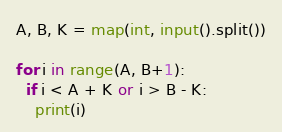<code> <loc_0><loc_0><loc_500><loc_500><_Python_>A, B, K = map(int, input().split())

for i in range(A, B+1):
  if i < A + K or i > B - K:
    print(i)
</code> 